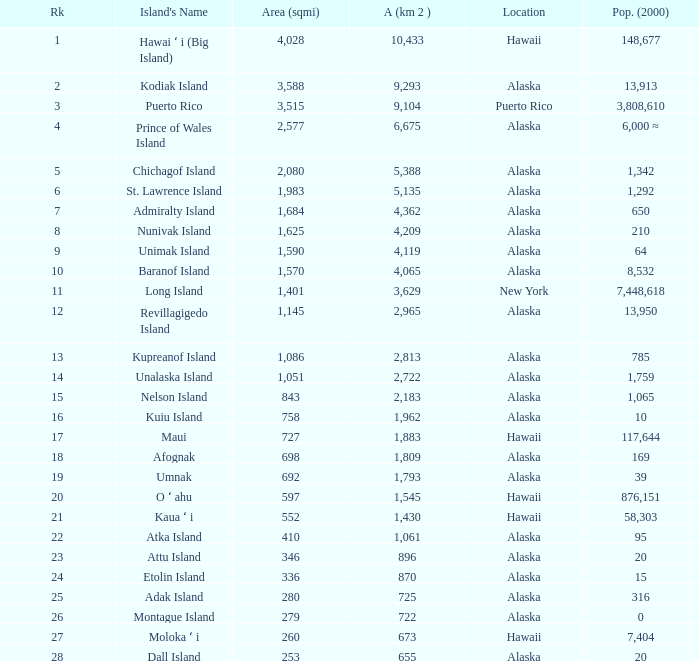What is the highest rank for Nelson Island with area more than 2,183? None. 